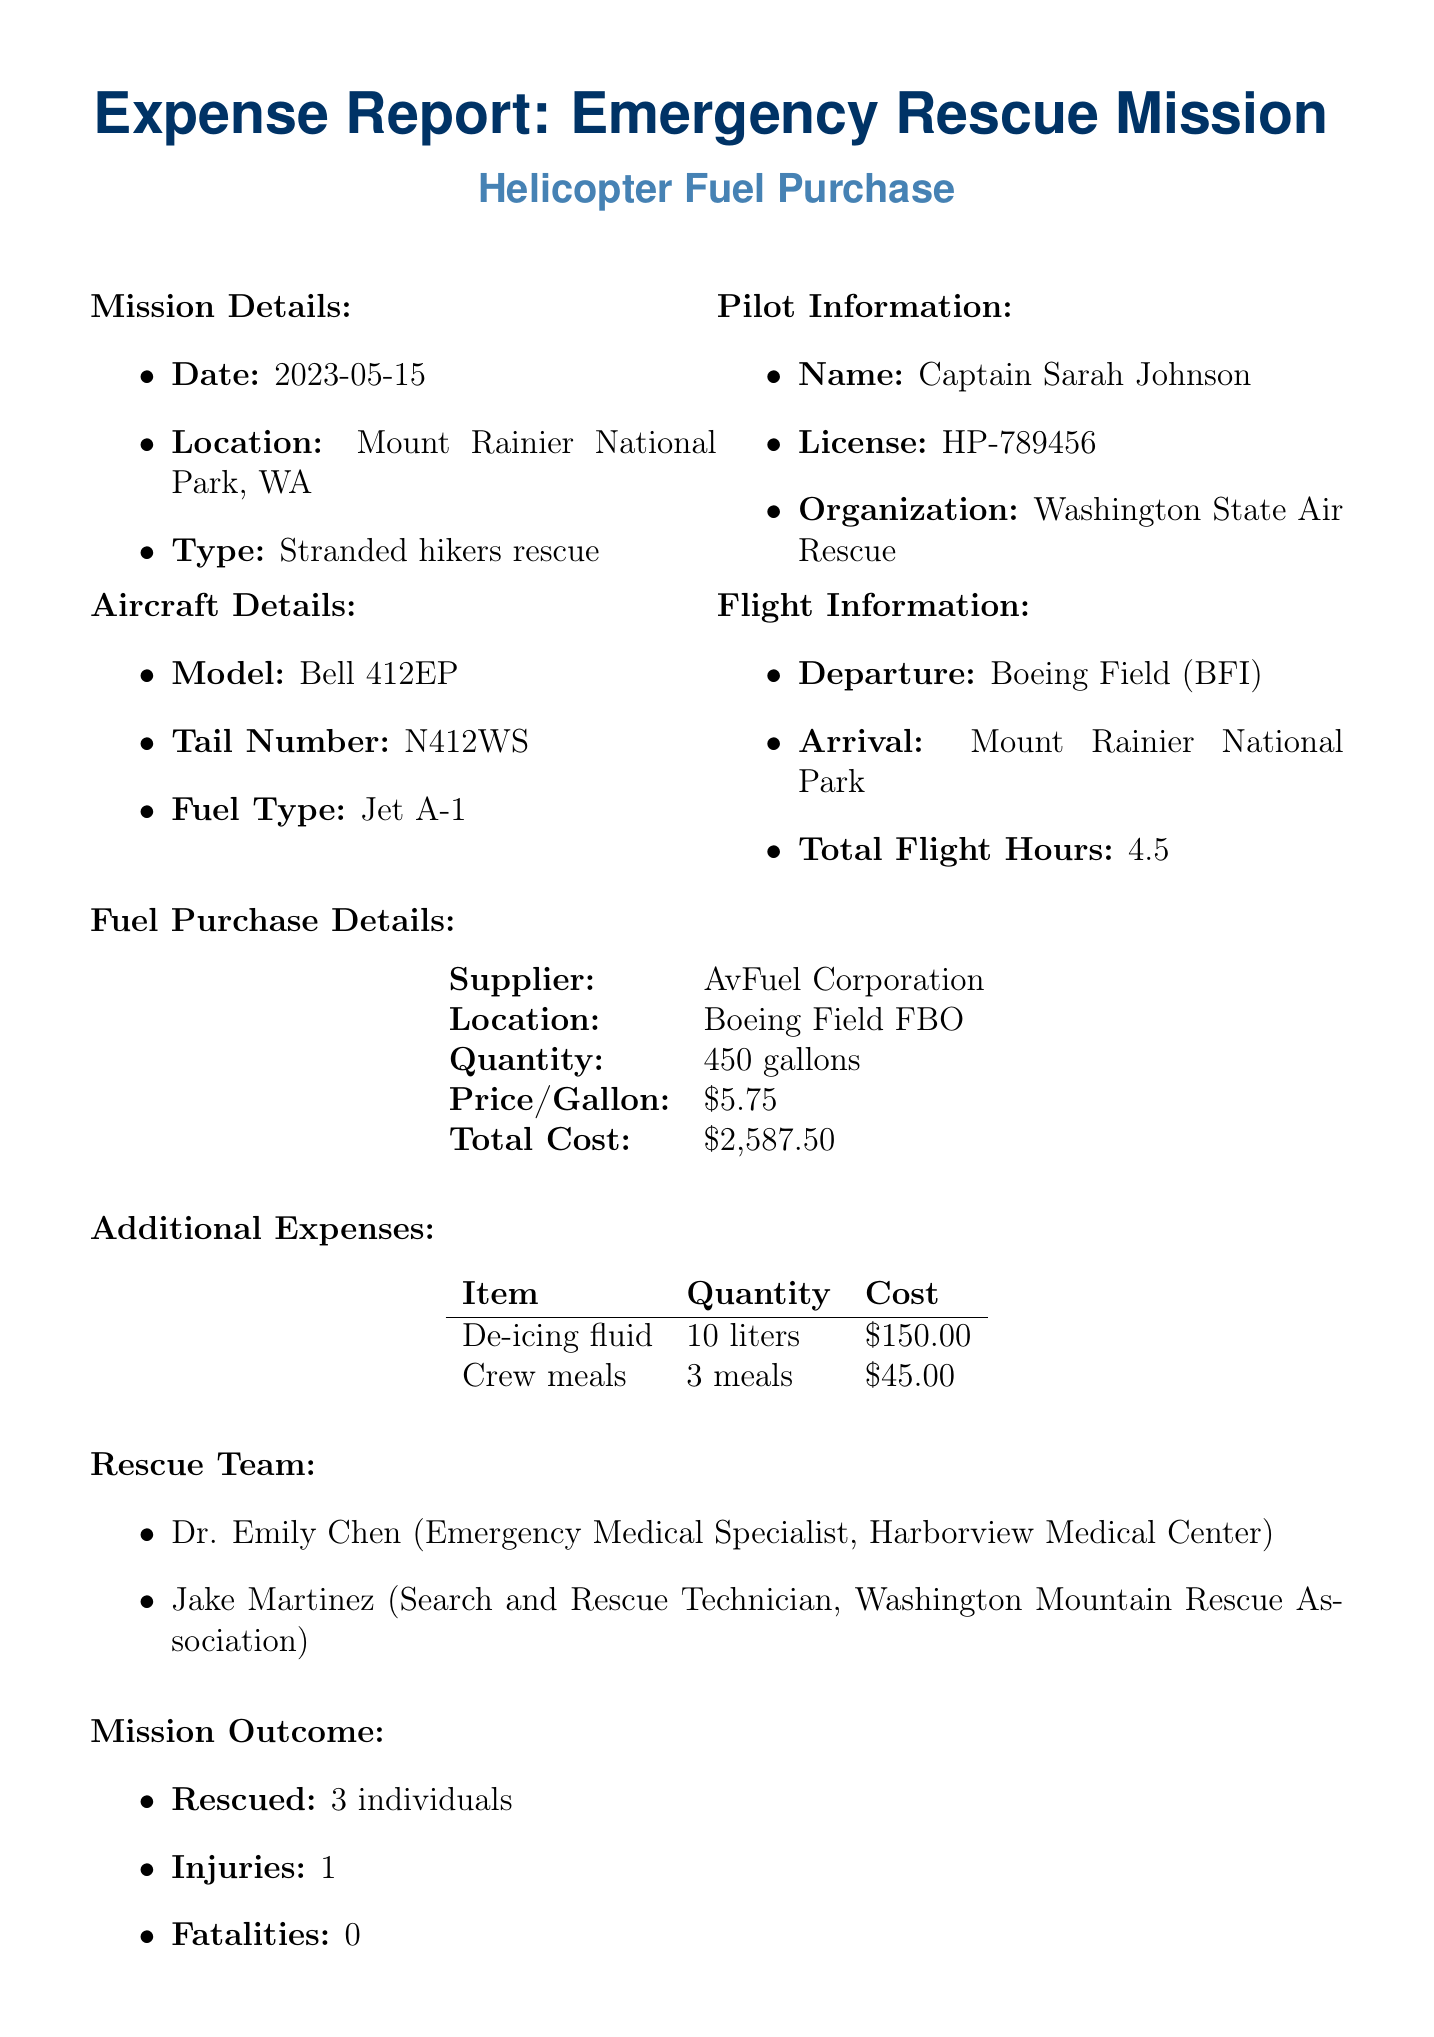What is the date of the mission? The date of the mission is listed under mission details, which is May 15, 2023.
Answer: May 15, 2023 Who was the pilot? The pilot's name is provided in the pilot information section, which states Captain Sarah Johnson.
Answer: Captain Sarah Johnson What type of helicopter was used? The aircraft details specify the model as Bell 412EP.
Answer: Bell 412EP What is the total cost of fuel? The total cost of fuel is reported in the fuel purchase section, which states $2587.50.
Answer: $2587.50 How many individuals were rescued? The mission outcome section mentions that three individuals were rescued.
Answer: 3 What was the quantity of fuel purchased? The fuel purchase details specify that 450 gallons of fuel were purchased.
Answer: 450 gallons What organization does Dr. Emily Chen belong to? The rescue team section states that Dr. Emily Chen is from Harborview Medical Center.
Answer: Harborview Medical Center What was the mission duration in hours? The flight information section indicates that the mission duration was 6.2 hours.
Answer: 6.2 What was the weather condition during the rescue? The mission details highlight the severe weather conditions in which the rescue occurred.
Answer: Severe weather conditions 